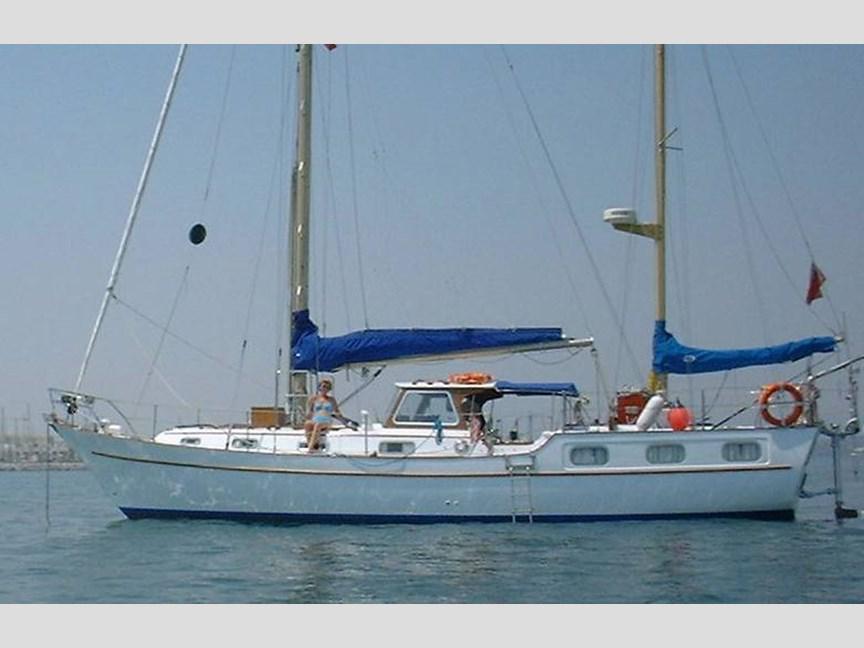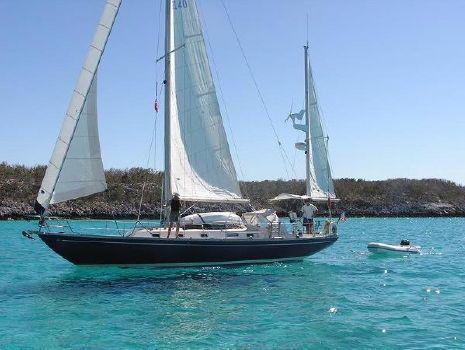The first image is the image on the left, the second image is the image on the right. Assess this claim about the two images: "One boat with a rider in a red jacket creates white spray as it moves through water with unfurled sails, while the other boat is still and has furled sails.". Correct or not? Answer yes or no. No. The first image is the image on the left, the second image is the image on the right. Analyze the images presented: Is the assertion "The left and right image contains a total of three boats." valid? Answer yes or no. Yes. 